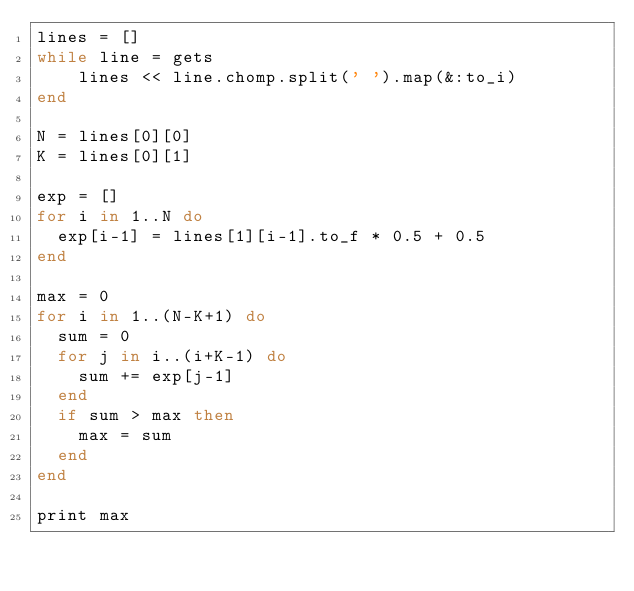Convert code to text. <code><loc_0><loc_0><loc_500><loc_500><_Ruby_>lines = []
while line = gets
    lines << line.chomp.split(' ').map(&:to_i)
end

N = lines[0][0]
K = lines[0][1]

exp = []
for i in 1..N do
  exp[i-1] = lines[1][i-1].to_f * 0.5 + 0.5
end

max = 0
for i in 1..(N-K+1) do
  sum = 0
  for j in i..(i+K-1) do
    sum += exp[j-1]
  end
  if sum > max then
    max = sum
  end
end
  
print max</code> 